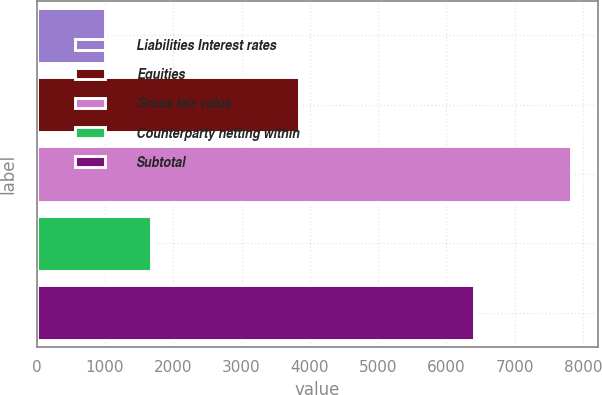Convert chart. <chart><loc_0><loc_0><loc_500><loc_500><bar_chart><fcel>Liabilities Interest rates<fcel>Equities<fcel>Gross fair value<fcel>Counterparty netting within<fcel>Subtotal<nl><fcel>995<fcel>3840<fcel>7824<fcel>1677.9<fcel>6407<nl></chart> 